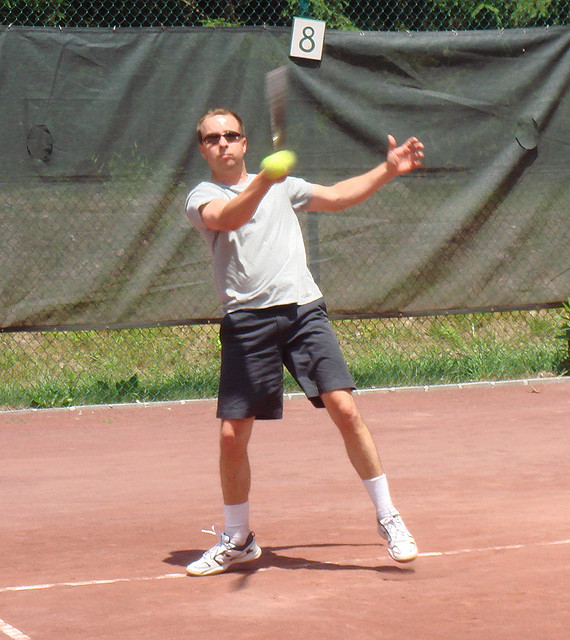<image>Why is the white cardboard with the number eight written on it on the fence? I don't know why the white cardboard with the number eight is on the fence. It could be a court number, match number, or to mark score. Why is the white cardboard with the number eight written on it on the fence? I don't know why the white cardboard with the number eight written on it is on the fence. It can be used to mark the score in a match. 